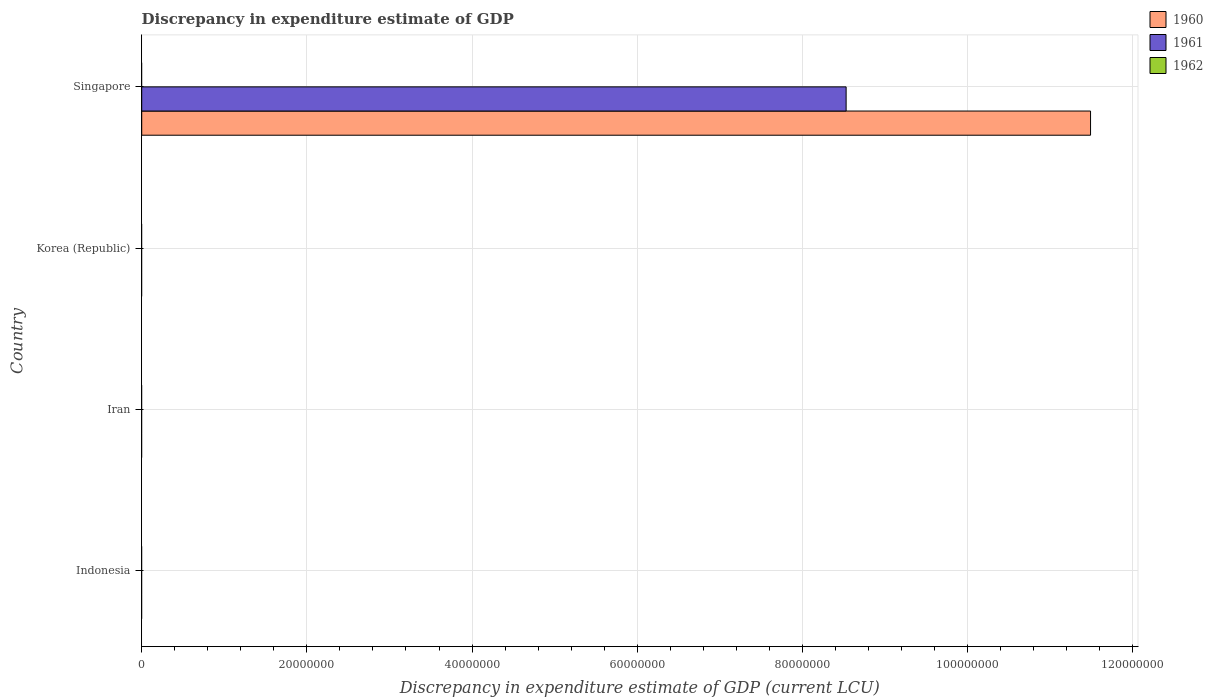Are the number of bars per tick equal to the number of legend labels?
Provide a succinct answer. No. How many bars are there on the 1st tick from the bottom?
Make the answer very short. 0. What is the label of the 2nd group of bars from the top?
Offer a very short reply. Korea (Republic). What is the discrepancy in expenditure estimate of GDP in 1961 in Indonesia?
Ensure brevity in your answer.  0. Across all countries, what is the maximum discrepancy in expenditure estimate of GDP in 1960?
Keep it short and to the point. 1.15e+08. In which country was the discrepancy in expenditure estimate of GDP in 1960 maximum?
Keep it short and to the point. Singapore. What is the difference between the discrepancy in expenditure estimate of GDP in 1961 in Singapore and the discrepancy in expenditure estimate of GDP in 1960 in Korea (Republic)?
Offer a very short reply. 8.53e+07. What is the difference between the discrepancy in expenditure estimate of GDP in 1961 and discrepancy in expenditure estimate of GDP in 1960 in Singapore?
Make the answer very short. -2.96e+07. In how many countries, is the discrepancy in expenditure estimate of GDP in 1961 greater than 44000000 LCU?
Your answer should be compact. 1. What is the difference between the highest and the lowest discrepancy in expenditure estimate of GDP in 1961?
Keep it short and to the point. 8.53e+07. In how many countries, is the discrepancy in expenditure estimate of GDP in 1960 greater than the average discrepancy in expenditure estimate of GDP in 1960 taken over all countries?
Your response must be concise. 1. How many bars are there?
Give a very brief answer. 2. Does the graph contain grids?
Keep it short and to the point. Yes. Where does the legend appear in the graph?
Your answer should be very brief. Top right. How many legend labels are there?
Give a very brief answer. 3. How are the legend labels stacked?
Keep it short and to the point. Vertical. What is the title of the graph?
Give a very brief answer. Discrepancy in expenditure estimate of GDP. What is the label or title of the X-axis?
Provide a short and direct response. Discrepancy in expenditure estimate of GDP (current LCU). What is the Discrepancy in expenditure estimate of GDP (current LCU) in 1962 in Indonesia?
Provide a short and direct response. 0. What is the Discrepancy in expenditure estimate of GDP (current LCU) of 1960 in Iran?
Ensure brevity in your answer.  0. What is the Discrepancy in expenditure estimate of GDP (current LCU) in 1961 in Korea (Republic)?
Provide a succinct answer. 0. What is the Discrepancy in expenditure estimate of GDP (current LCU) of 1960 in Singapore?
Your answer should be very brief. 1.15e+08. What is the Discrepancy in expenditure estimate of GDP (current LCU) of 1961 in Singapore?
Make the answer very short. 8.53e+07. What is the Discrepancy in expenditure estimate of GDP (current LCU) of 1962 in Singapore?
Provide a succinct answer. 0. Across all countries, what is the maximum Discrepancy in expenditure estimate of GDP (current LCU) in 1960?
Keep it short and to the point. 1.15e+08. Across all countries, what is the maximum Discrepancy in expenditure estimate of GDP (current LCU) in 1961?
Keep it short and to the point. 8.53e+07. What is the total Discrepancy in expenditure estimate of GDP (current LCU) of 1960 in the graph?
Provide a short and direct response. 1.15e+08. What is the total Discrepancy in expenditure estimate of GDP (current LCU) in 1961 in the graph?
Your response must be concise. 8.53e+07. What is the total Discrepancy in expenditure estimate of GDP (current LCU) of 1962 in the graph?
Provide a short and direct response. 0. What is the average Discrepancy in expenditure estimate of GDP (current LCU) of 1960 per country?
Provide a short and direct response. 2.87e+07. What is the average Discrepancy in expenditure estimate of GDP (current LCU) of 1961 per country?
Offer a terse response. 2.13e+07. What is the average Discrepancy in expenditure estimate of GDP (current LCU) in 1962 per country?
Offer a very short reply. 0. What is the difference between the Discrepancy in expenditure estimate of GDP (current LCU) of 1960 and Discrepancy in expenditure estimate of GDP (current LCU) of 1961 in Singapore?
Offer a terse response. 2.96e+07. What is the difference between the highest and the lowest Discrepancy in expenditure estimate of GDP (current LCU) of 1960?
Make the answer very short. 1.15e+08. What is the difference between the highest and the lowest Discrepancy in expenditure estimate of GDP (current LCU) of 1961?
Provide a succinct answer. 8.53e+07. 